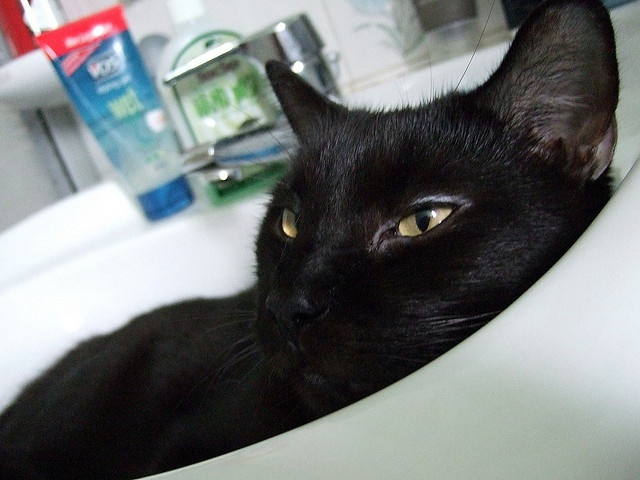Describe the objects in this image and their specific colors. I can see cat in brown, black, gray, and darkgray tones and sink in brown, white, darkgray, lightgray, and gray tones in this image. 